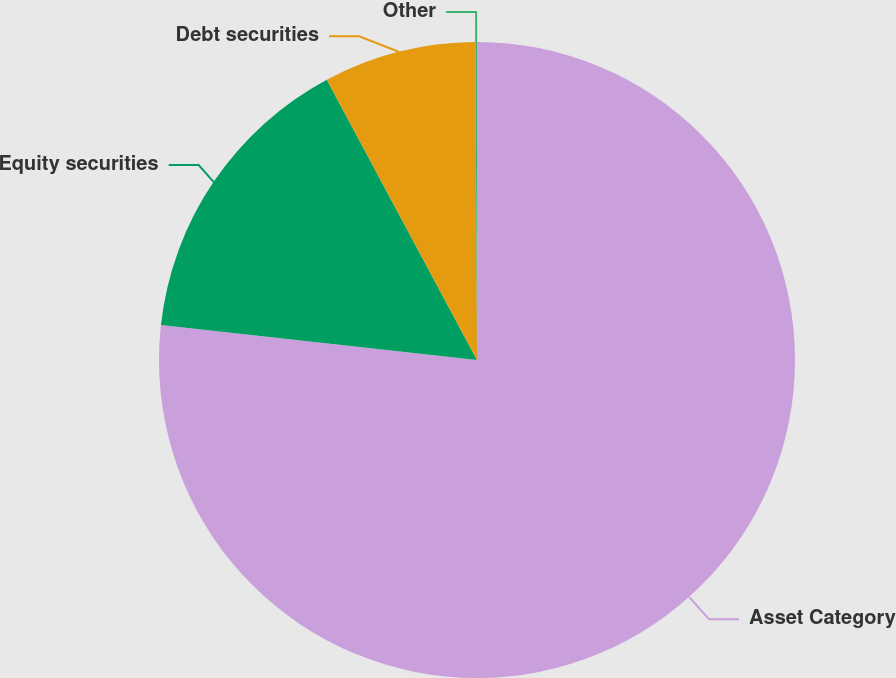<chart> <loc_0><loc_0><loc_500><loc_500><pie_chart><fcel>Asset Category<fcel>Equity securities<fcel>Debt securities<fcel>Other<nl><fcel>76.76%<fcel>15.41%<fcel>7.75%<fcel>0.08%<nl></chart> 